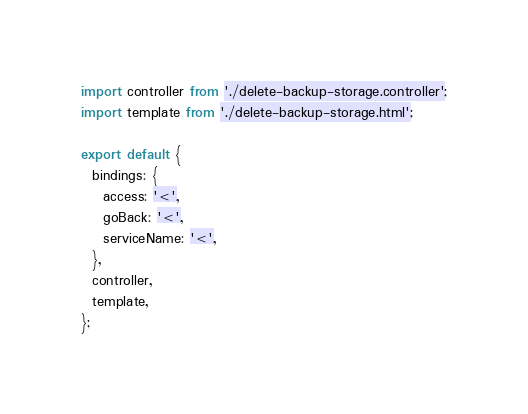<code> <loc_0><loc_0><loc_500><loc_500><_JavaScript_>import controller from './delete-backup-storage.controller';
import template from './delete-backup-storage.html';

export default {
  bindings: {
    access: '<',
    goBack: '<',
    serviceName: '<',
  },
  controller,
  template,
};
</code> 